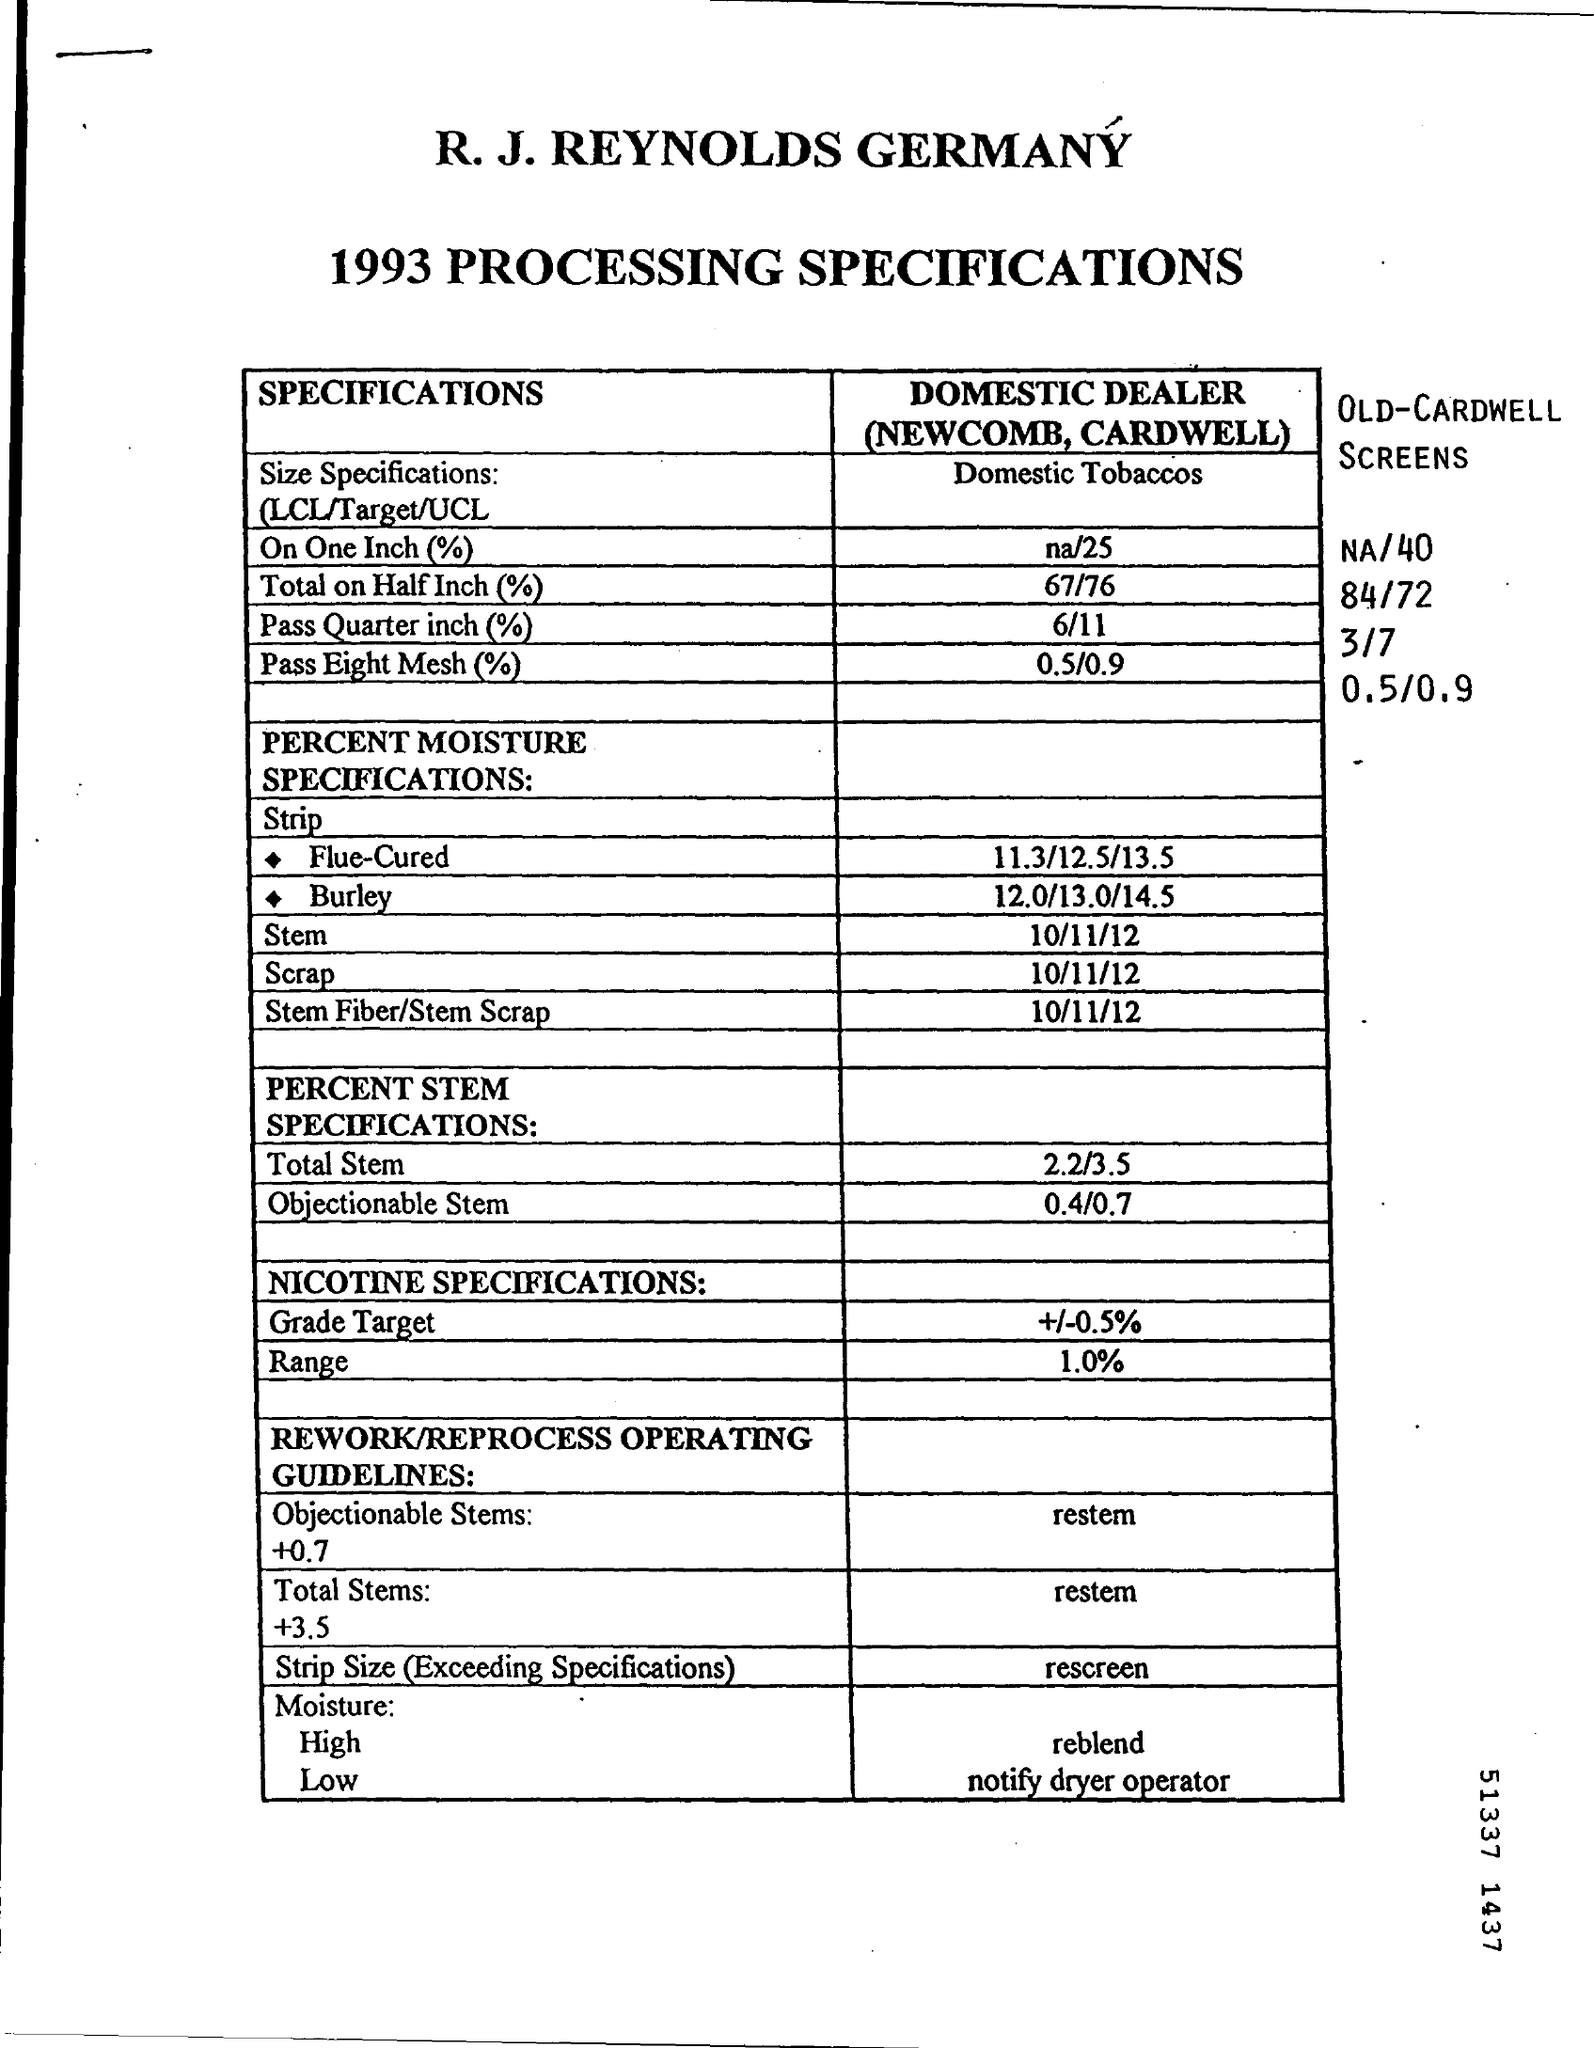Draw attention to some important aspects in this diagram. The scrap date mentioned on the cover sheet is 10/11/12. 